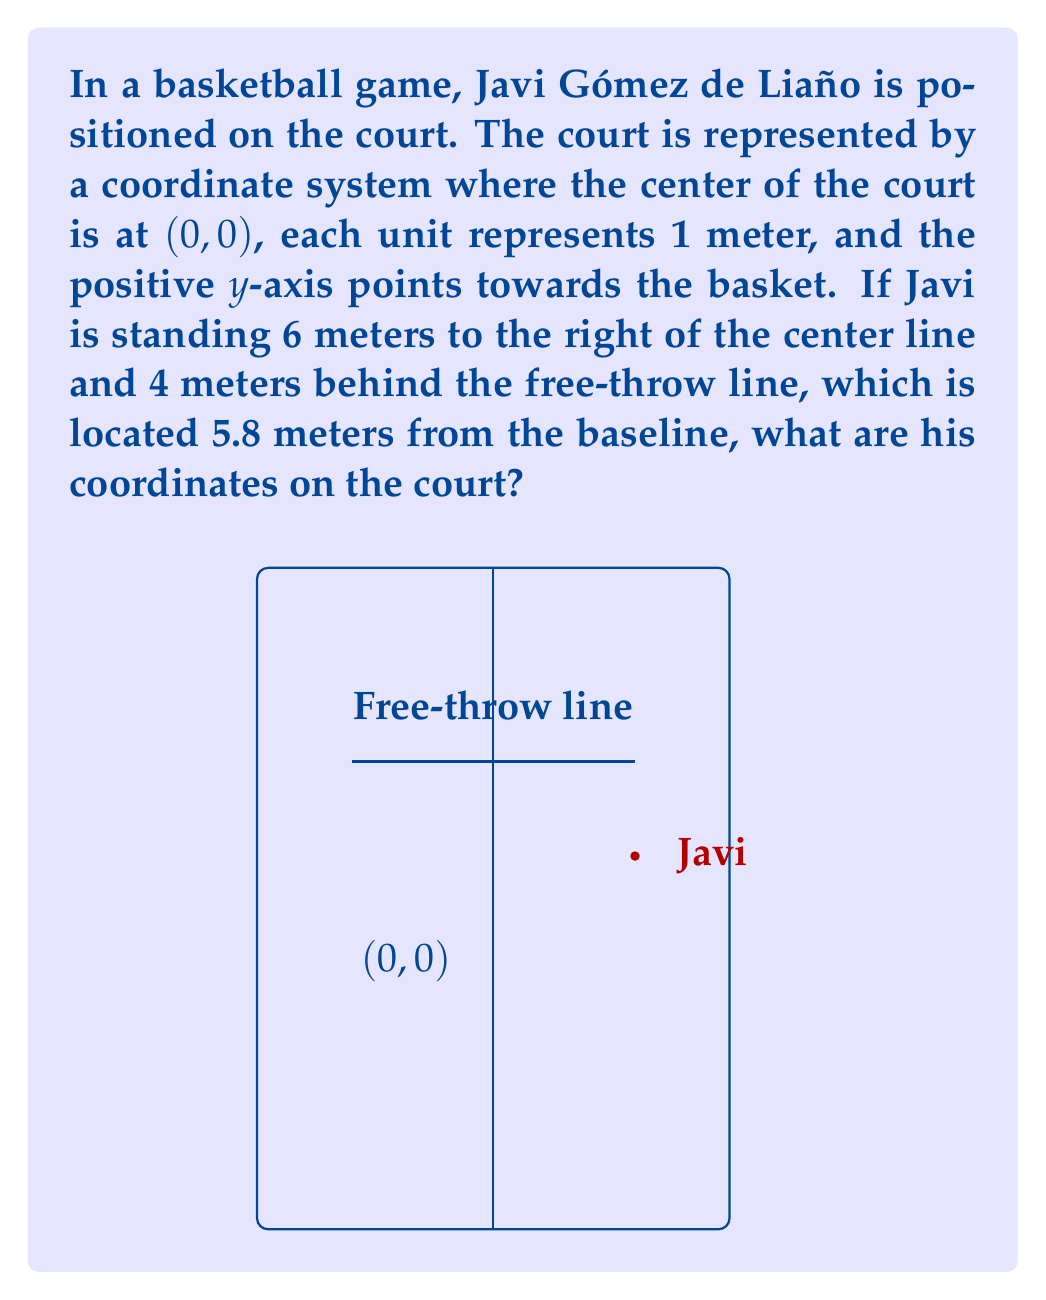Can you answer this question? To solve this problem, let's follow these steps:

1) First, we need to understand the given information:
   - The center of the court is at (0, 0)
   - Javi is 6 meters to the right of the center line
   - The free-throw line is 5.8 meters from the baseline
   - Javi is 4 meters behind the free-throw line

2) Since Javi is 6 meters to the right of the center line, his x-coordinate will be 6.

3) To find his y-coordinate, we need to:
   a) Start from the baseline (which would be at y = -14 if each half-court is 14 meters long)
   b) Move up to the free-throw line: -14 + 5.8 = -8.2
   c) Then move 4 meters back from the free-throw line

4) So, his y-coordinate will be: $y = -8.2 - 4 = -12.2$

5) Therefore, Javi's coordinates are (6, -12.2)

To verify:
- He is 6 units to the right of the center line (x = 6)
- He is $14 - 12.2 = 1.8$ meters from the baseline, which is indeed 4 meters behind the free-throw line (5.8 - 4 = 1.8)
Answer: (6, -12.2) 